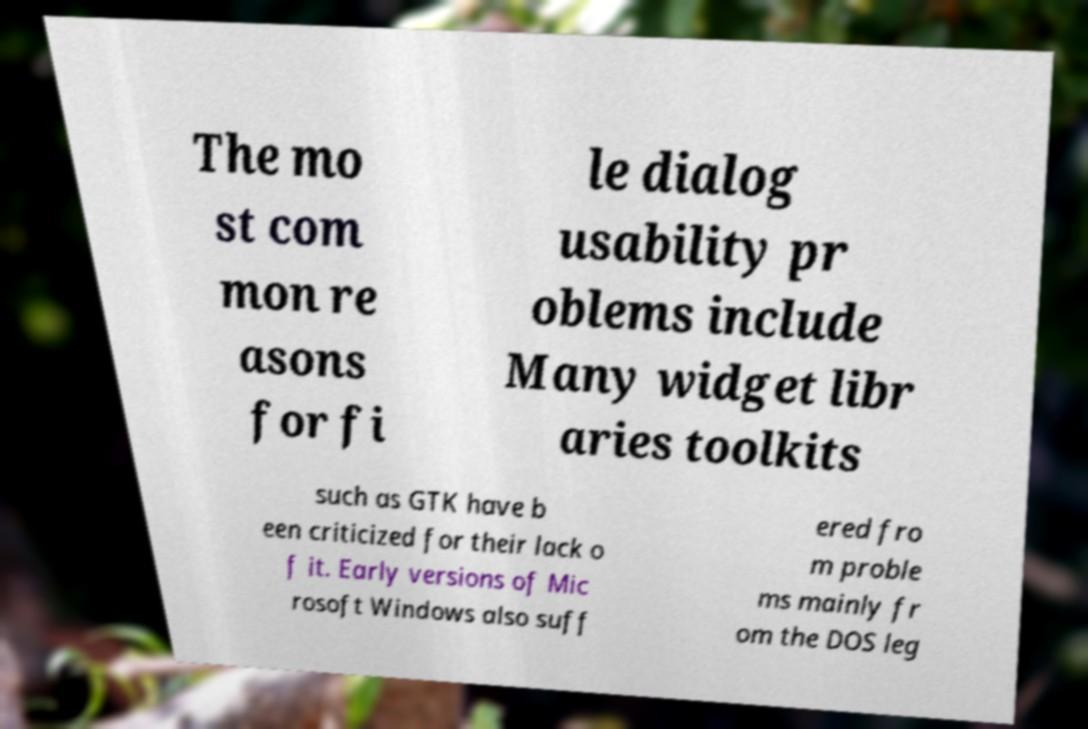What messages or text are displayed in this image? I need them in a readable, typed format. The mo st com mon re asons for fi le dialog usability pr oblems include Many widget libr aries toolkits such as GTK have b een criticized for their lack o f it. Early versions of Mic rosoft Windows also suff ered fro m proble ms mainly fr om the DOS leg 